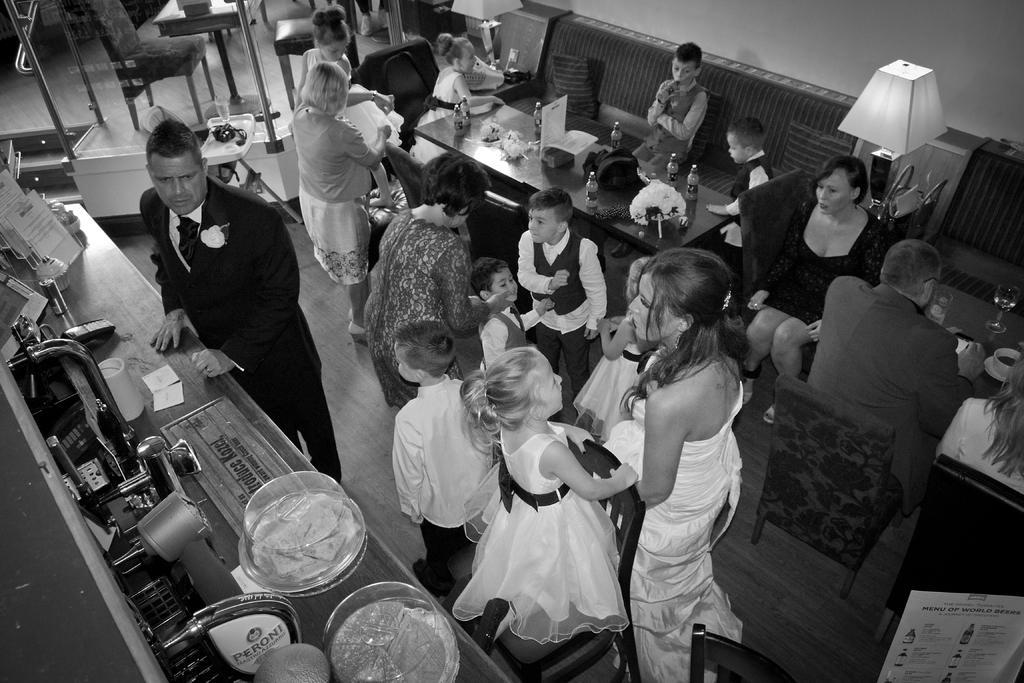How would you summarize this image in a sentence or two? In this picture I can see there are few people sitting and few people are standing, there are men, women, kids and there are tables at right side, there are machines at left side and there is one food places in the plate. 